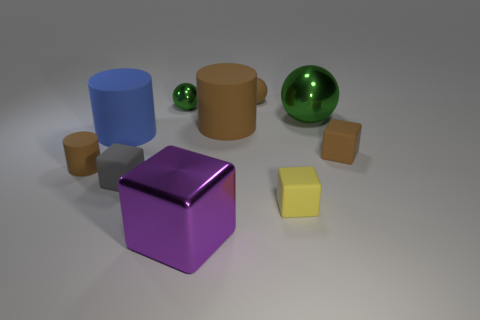How many objects are there in total, and can you categorize them by shape? In total, there are nine objects within the image. They can be categorized into four groups by shape: one cylinder, one sphere, two cubes, and five rectangular prisms.  Which objects appear to have a reflective surface? The objects with reflective surfaces in this image are the sphere and the larger cube, both glistening and casting discernible reflections on the surface they rest upon. 